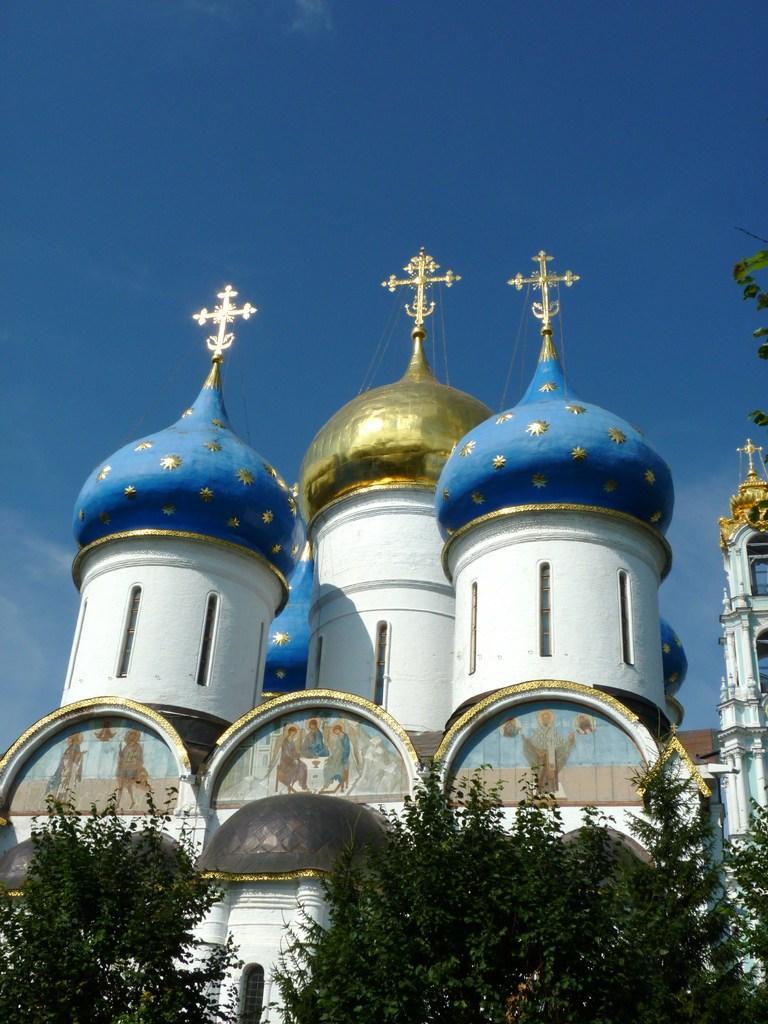Describe this image in one or two sentences. In the picture we can see a church building with three cross symbols on top of it with three pillars one is blue in color one is gold in color and one is blue in color and near to the church we can see some plants and in the background we can see a sky. 